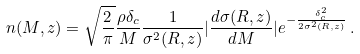Convert formula to latex. <formula><loc_0><loc_0><loc_500><loc_500>n ( M , z ) = \sqrt { \frac { 2 } { \pi } } \frac { \rho \delta _ { c } } { M } \frac { 1 } { \sigma ^ { 2 } ( R , z ) } | \frac { d \sigma ( R , z ) } { d M } | e ^ { - \frac { \delta ^ { 2 } _ { c } } { 2 \sigma ^ { 2 } ( R , z ) } } \, .</formula> 